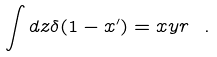Convert formula to latex. <formula><loc_0><loc_0><loc_500><loc_500>\int d z \delta ( 1 - x ^ { \prime } ) = x y r \ .</formula> 